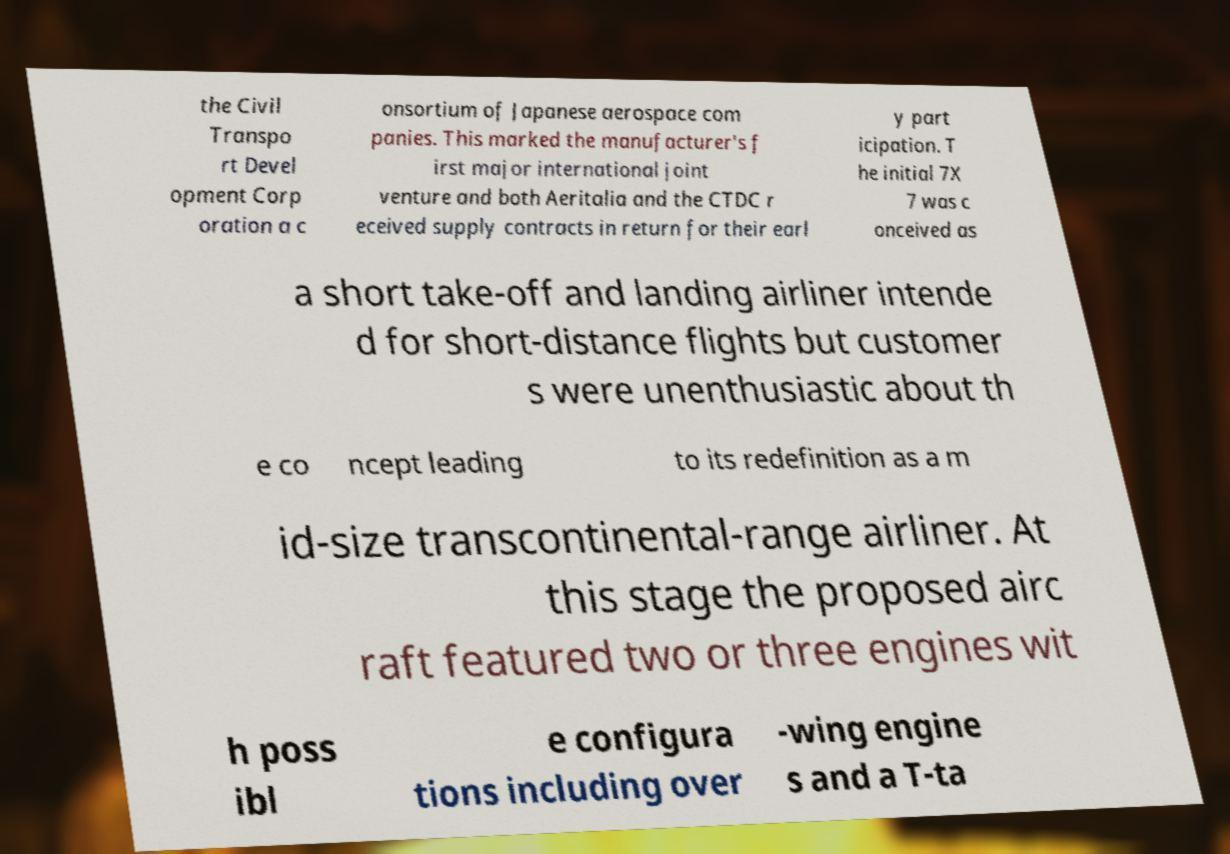Please read and relay the text visible in this image. What does it say? the Civil Transpo rt Devel opment Corp oration a c onsortium of Japanese aerospace com panies. This marked the manufacturer's f irst major international joint venture and both Aeritalia and the CTDC r eceived supply contracts in return for their earl y part icipation. T he initial 7X 7 was c onceived as a short take-off and landing airliner intende d for short-distance flights but customer s were unenthusiastic about th e co ncept leading to its redefinition as a m id-size transcontinental-range airliner. At this stage the proposed airc raft featured two or three engines wit h poss ibl e configura tions including over -wing engine s and a T-ta 